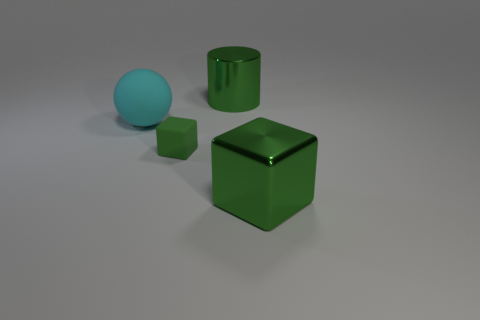Add 3 large cyan things. How many objects exist? 7 Subtract all big brown shiny blocks. Subtract all large green cubes. How many objects are left? 3 Add 2 cyan things. How many cyan things are left? 3 Add 4 big green matte cylinders. How many big green matte cylinders exist? 4 Subtract 0 cyan cubes. How many objects are left? 4 Subtract all cylinders. How many objects are left? 3 